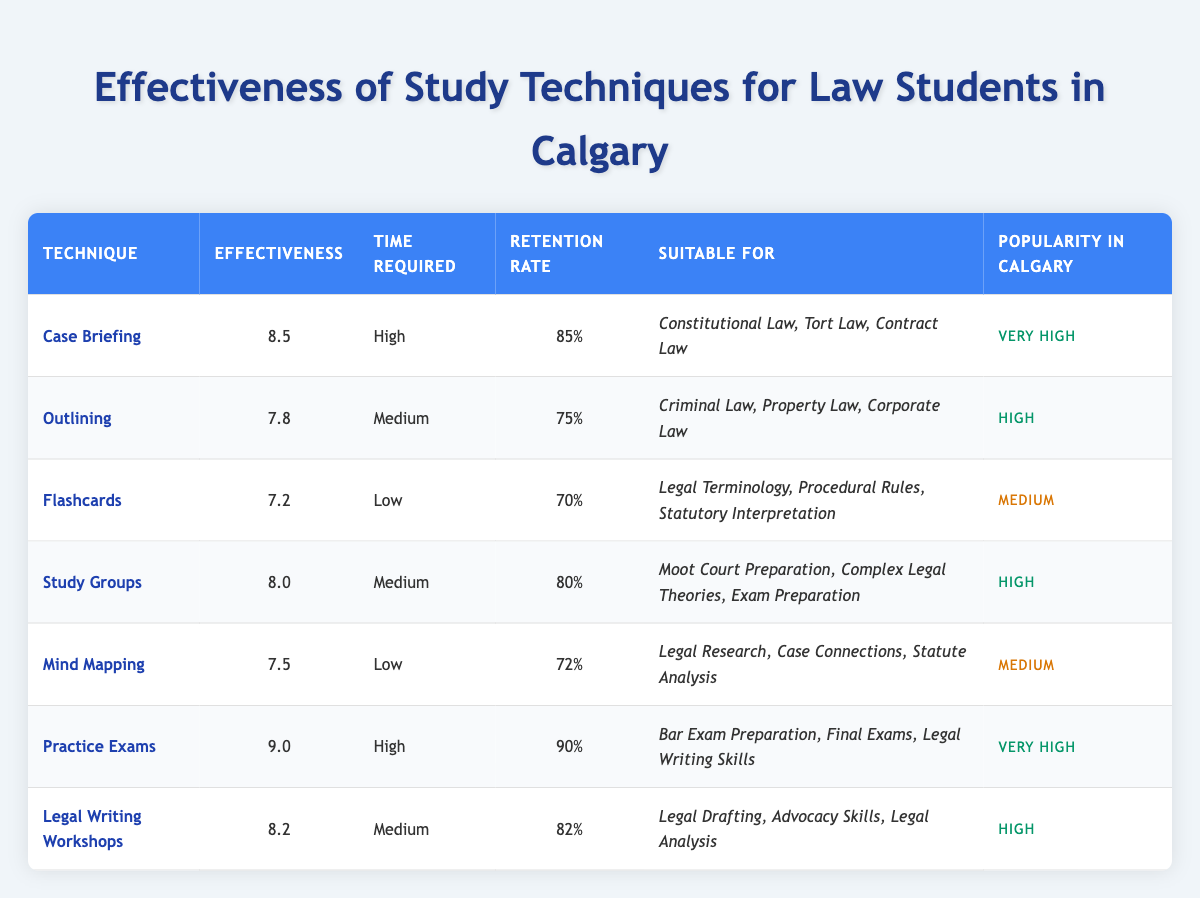What is the effectiveness rating of Case Briefing? Looking at the table, the effectiveness for the technique "Case Briefing" is listed right next to the technique under the "Effectiveness" column. It shows a rating of 8.5.
Answer: 8.5 Which study technique has the highest retention rate? In the "Retention Rate" column, the technique "Practice Exams" has the highest retention rate at 90%, which is higher than all the other techniques listed.
Answer: Practice Exams Is Flashcards suitable for Criminal Law? The "Suitable For" column specifies that "Flashcards" is suited for "Legal Terminology", "Procedural Rules", and "Statutory Interpretation". Criminal Law is not listed, indicating it is not suitable.
Answer: No What is the average effectiveness of the techniques suitable for Constitutional Law? The techniques suitable for "Constitutional Law" are "Case Briefing" and "Practice Exams". Their effectiveness ratings are 8.5 and 9.0, respectively. The average is calculated as (8.5 + 9.0) / 2 = 8.75.
Answer: 8.75 How many techniques have a low time requirement? Reviewing the "Time Required" column, "Flashcards" and "Mind Mapping" are categorized as having a "Low" time requirement, totaling 2 techniques.
Answer: 2 Is the popularity of Outlining higher than that of Mind Mapping? The "Popularity in Calgary" column shows that "Outlining" is rated as "High" and "Mind Mapping" is rated as "Medium". Since "High" is greater than "Medium", the popularity of Outlining is indeed higher.
Answer: Yes Which technique has a retention rate of 80%? Looking at the retention rates in the "Retention Rate" column, the technique "Study Groups" has a retention rate of 80%, making it the only technique with this particular rate.
Answer: Study Groups What is the difference in effectiveness between Practice Exams and Legal Writing Workshops? The effectiveness for "Practice Exams" is 9.0, while "Legal Writing Workshops" is 8.2. To find the difference, subtract 8.2 from 9.0, resulting in an effectiveness difference of 0.8.
Answer: 0.8 How many techniques are rated as "Very High" in popularity? In the "Popularity in Calgary" column, both "Case Briefing" and "Practice Exams" are rated as "Very High", hence there are 2 techniques with this popularity level.
Answer: 2 